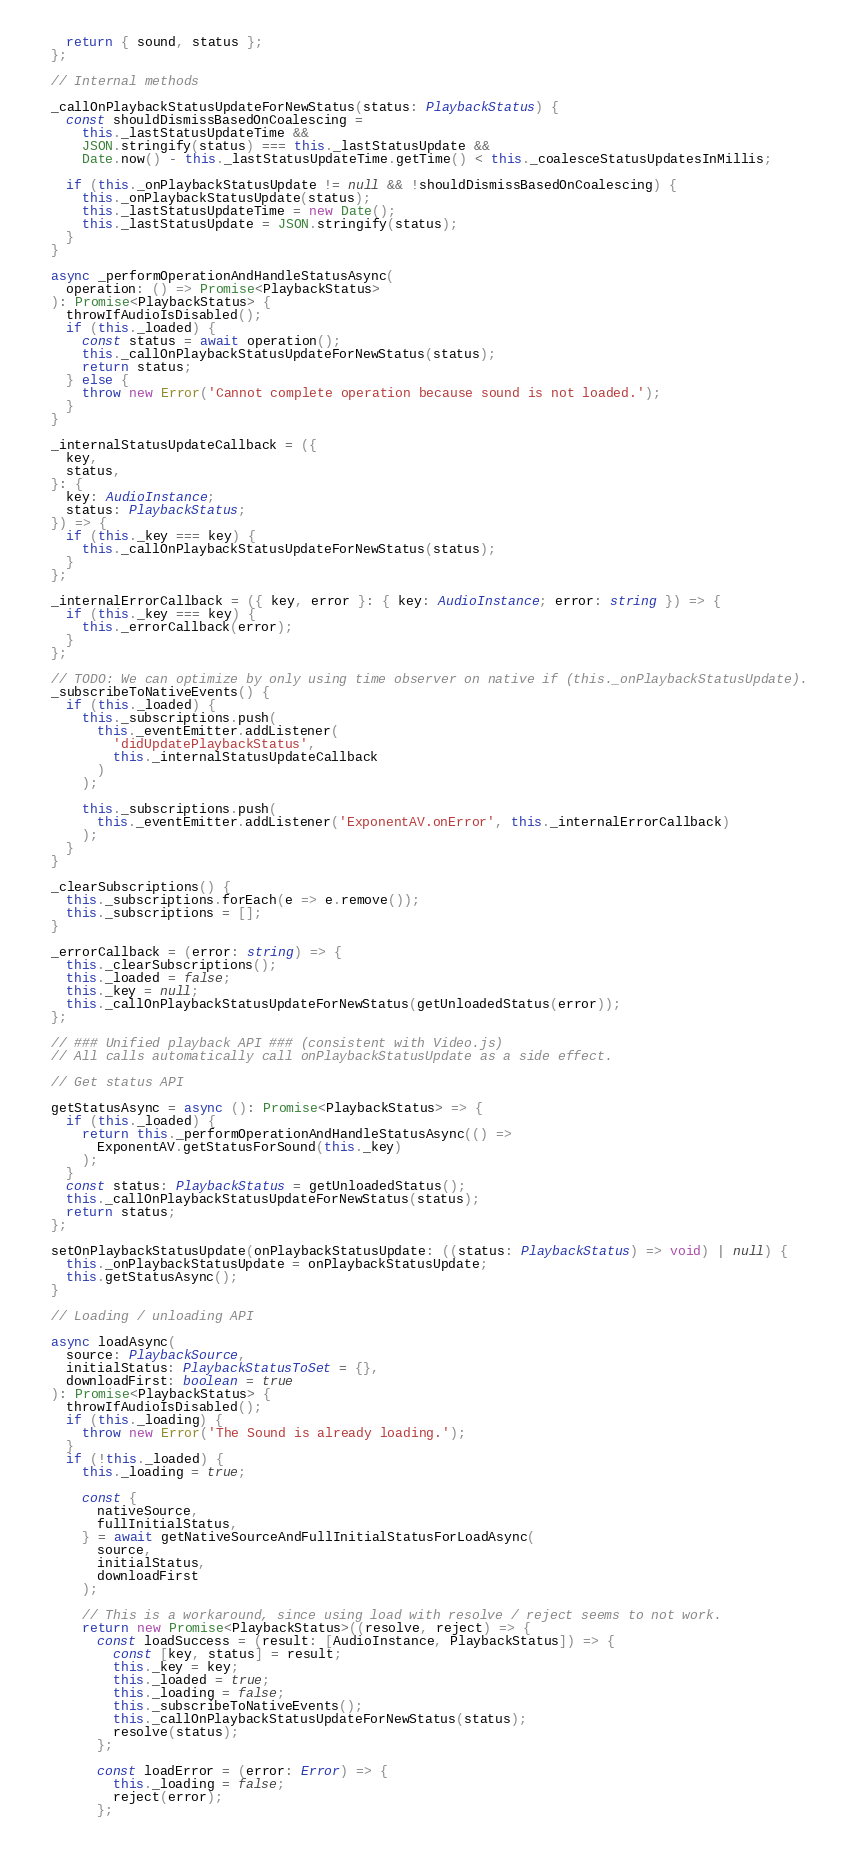<code> <loc_0><loc_0><loc_500><loc_500><_TypeScript_>    return { sound, status };
  };

  // Internal methods

  _callOnPlaybackStatusUpdateForNewStatus(status: PlaybackStatus) {
    const shouldDismissBasedOnCoalescing =
      this._lastStatusUpdateTime &&
      JSON.stringify(status) === this._lastStatusUpdate &&
      Date.now() - this._lastStatusUpdateTime.getTime() < this._coalesceStatusUpdatesInMillis;

    if (this._onPlaybackStatusUpdate != null && !shouldDismissBasedOnCoalescing) {
      this._onPlaybackStatusUpdate(status);
      this._lastStatusUpdateTime = new Date();
      this._lastStatusUpdate = JSON.stringify(status);
    }
  }

  async _performOperationAndHandleStatusAsync(
    operation: () => Promise<PlaybackStatus>
  ): Promise<PlaybackStatus> {
    throwIfAudioIsDisabled();
    if (this._loaded) {
      const status = await operation();
      this._callOnPlaybackStatusUpdateForNewStatus(status);
      return status;
    } else {
      throw new Error('Cannot complete operation because sound is not loaded.');
    }
  }

  _internalStatusUpdateCallback = ({
    key,
    status,
  }: {
    key: AudioInstance;
    status: PlaybackStatus;
  }) => {
    if (this._key === key) {
      this._callOnPlaybackStatusUpdateForNewStatus(status);
    }
  };

  _internalErrorCallback = ({ key, error }: { key: AudioInstance; error: string }) => {
    if (this._key === key) {
      this._errorCallback(error);
    }
  };

  // TODO: We can optimize by only using time observer on native if (this._onPlaybackStatusUpdate).
  _subscribeToNativeEvents() {
    if (this._loaded) {
      this._subscriptions.push(
        this._eventEmitter.addListener(
          'didUpdatePlaybackStatus',
          this._internalStatusUpdateCallback
        )
      );

      this._subscriptions.push(
        this._eventEmitter.addListener('ExponentAV.onError', this._internalErrorCallback)
      );
    }
  }

  _clearSubscriptions() {
    this._subscriptions.forEach(e => e.remove());
    this._subscriptions = [];
  }

  _errorCallback = (error: string) => {
    this._clearSubscriptions();
    this._loaded = false;
    this._key = null;
    this._callOnPlaybackStatusUpdateForNewStatus(getUnloadedStatus(error));
  };

  // ### Unified playback API ### (consistent with Video.js)
  // All calls automatically call onPlaybackStatusUpdate as a side effect.

  // Get status API

  getStatusAsync = async (): Promise<PlaybackStatus> => {
    if (this._loaded) {
      return this._performOperationAndHandleStatusAsync(() =>
        ExponentAV.getStatusForSound(this._key)
      );
    }
    const status: PlaybackStatus = getUnloadedStatus();
    this._callOnPlaybackStatusUpdateForNewStatus(status);
    return status;
  };

  setOnPlaybackStatusUpdate(onPlaybackStatusUpdate: ((status: PlaybackStatus) => void) | null) {
    this._onPlaybackStatusUpdate = onPlaybackStatusUpdate;
    this.getStatusAsync();
  }

  // Loading / unloading API

  async loadAsync(
    source: PlaybackSource,
    initialStatus: PlaybackStatusToSet = {},
    downloadFirst: boolean = true
  ): Promise<PlaybackStatus> {
    throwIfAudioIsDisabled();
    if (this._loading) {
      throw new Error('The Sound is already loading.');
    }
    if (!this._loaded) {
      this._loading = true;

      const {
        nativeSource,
        fullInitialStatus,
      } = await getNativeSourceAndFullInitialStatusForLoadAsync(
        source,
        initialStatus,
        downloadFirst
      );

      // This is a workaround, since using load with resolve / reject seems to not work.
      return new Promise<PlaybackStatus>((resolve, reject) => {
        const loadSuccess = (result: [AudioInstance, PlaybackStatus]) => {
          const [key, status] = result;
          this._key = key;
          this._loaded = true;
          this._loading = false;
          this._subscribeToNativeEvents();
          this._callOnPlaybackStatusUpdateForNewStatus(status);
          resolve(status);
        };

        const loadError = (error: Error) => {
          this._loading = false;
          reject(error);
        };
</code> 